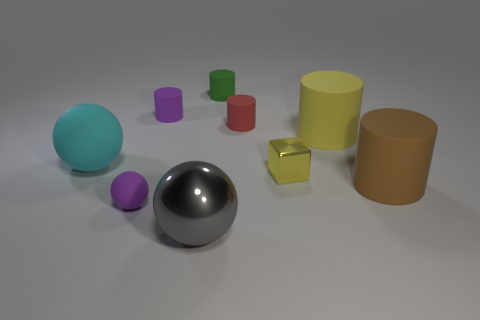Is the shape of the cyan rubber object the same as the large gray thing?
Ensure brevity in your answer.  Yes. There is a big rubber thing that is behind the cyan ball; what is its color?
Keep it short and to the point. Yellow. Does the brown matte cylinder have the same size as the green rubber cylinder?
Provide a short and direct response. No. The green object is what size?
Offer a terse response. Small. Are there more tiny brown shiny things than big matte spheres?
Offer a very short reply. No. There is a big rubber object that is on the left side of the small purple matte object that is behind the sphere behind the brown matte thing; what is its color?
Provide a short and direct response. Cyan. Do the purple rubber thing that is behind the yellow matte cylinder and the gray shiny thing have the same shape?
Make the answer very short. No. What is the color of the matte ball that is the same size as the gray thing?
Ensure brevity in your answer.  Cyan. What number of purple shiny cubes are there?
Your answer should be very brief. 0. Does the small purple ball that is left of the small red thing have the same material as the small yellow object?
Provide a short and direct response. No. 